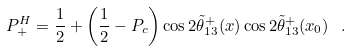<formula> <loc_0><loc_0><loc_500><loc_500>P ^ { H } _ { + } = \frac { 1 } { 2 } + \left ( \frac { 1 } { 2 } - P _ { c } \right ) \cos 2 \tilde { \theta } _ { 1 3 } ^ { + } ( x ) \cos 2 \tilde { \theta } _ { 1 3 } ^ { + } ( x _ { 0 } ) \, \ .</formula> 